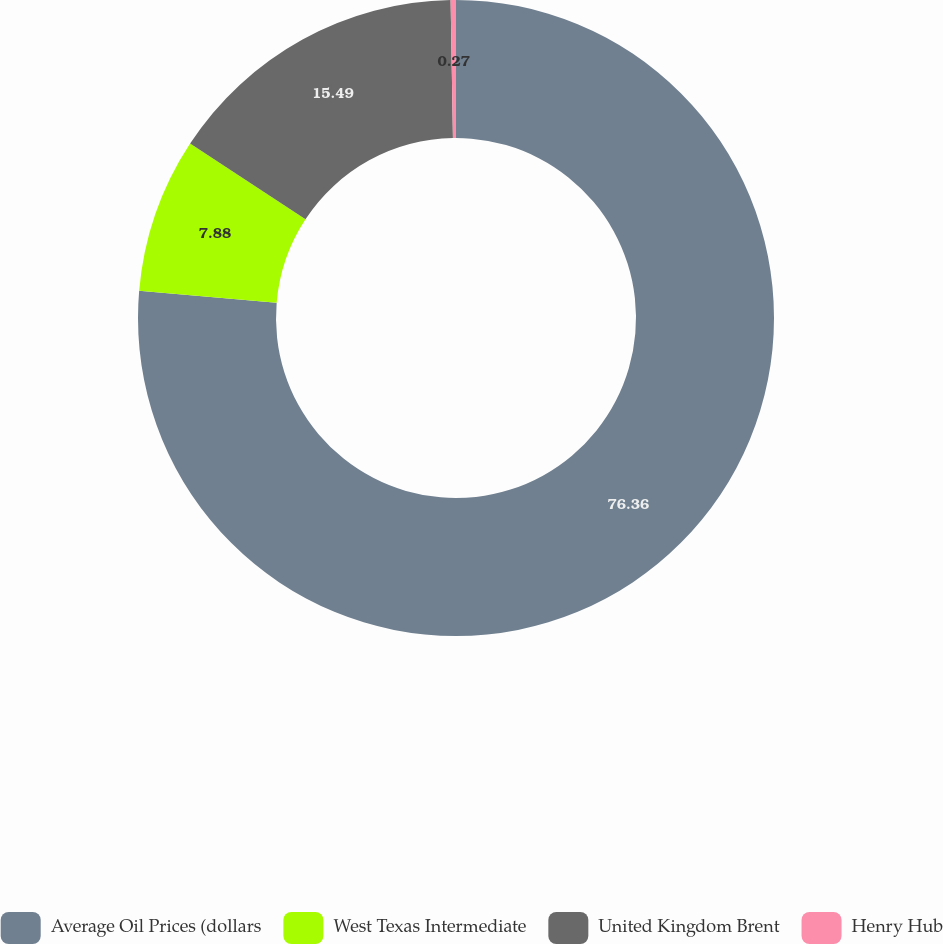<chart> <loc_0><loc_0><loc_500><loc_500><pie_chart><fcel>Average Oil Prices (dollars<fcel>West Texas Intermediate<fcel>United Kingdom Brent<fcel>Henry Hub<nl><fcel>76.36%<fcel>7.88%<fcel>15.49%<fcel>0.27%<nl></chart> 